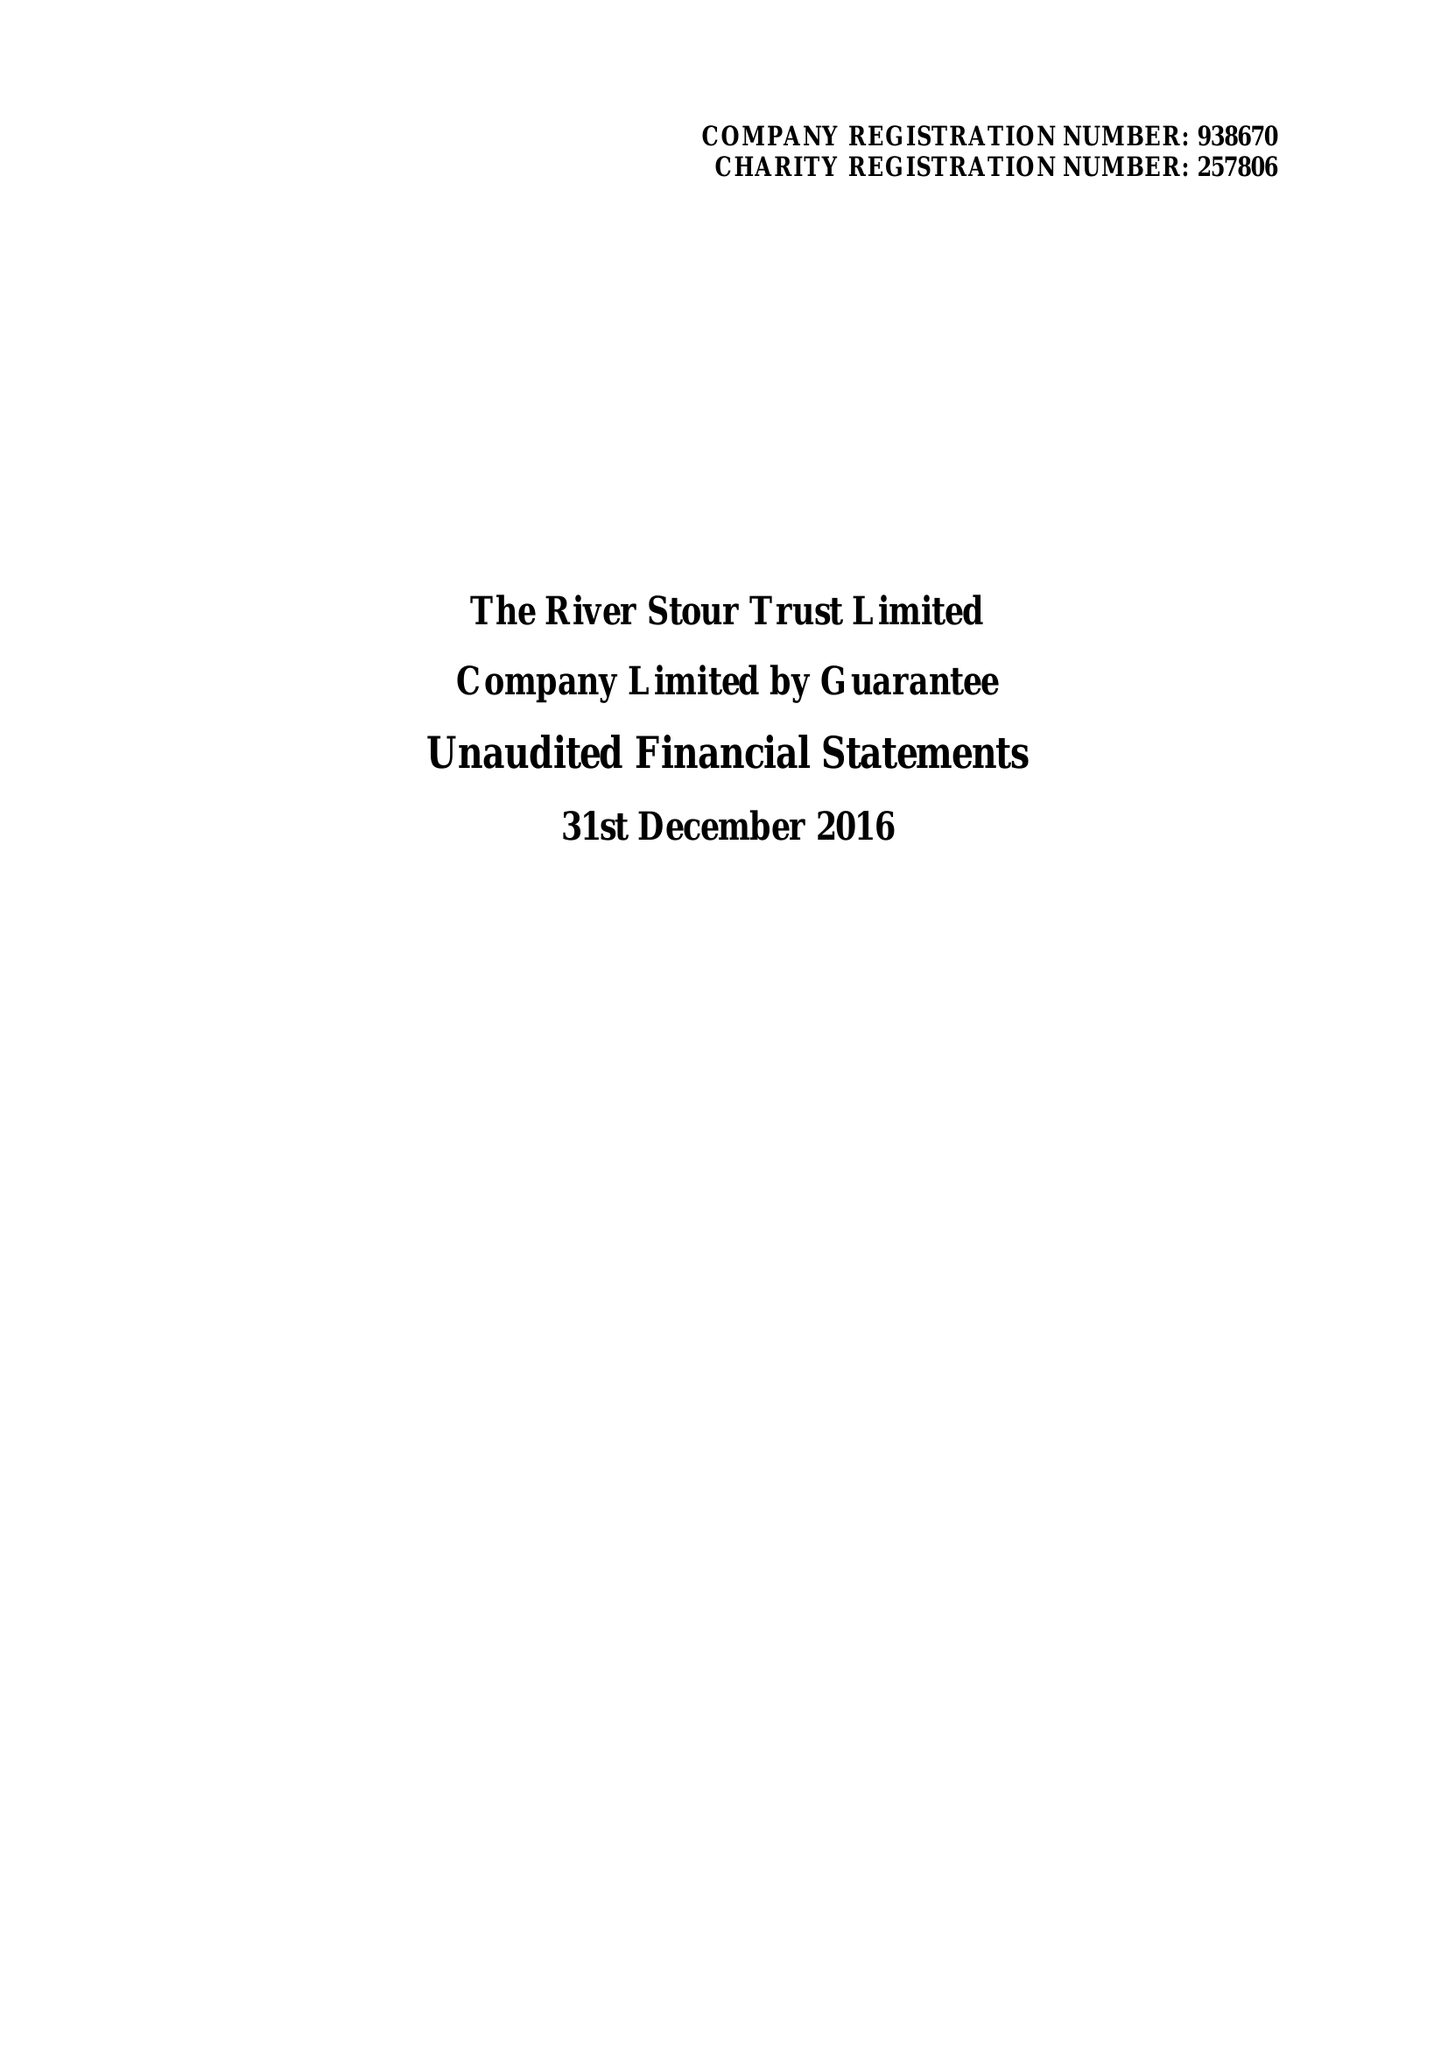What is the value for the address__post_town?
Answer the question using a single word or phrase. SUDBURY 